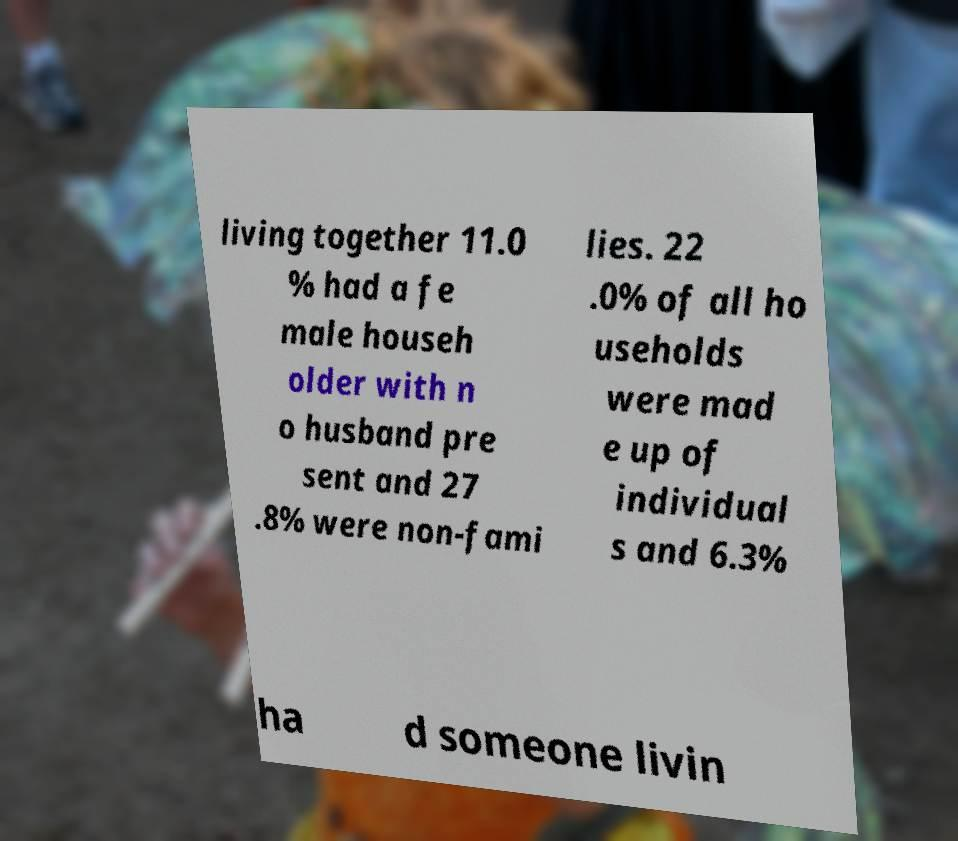I need the written content from this picture converted into text. Can you do that? living together 11.0 % had a fe male househ older with n o husband pre sent and 27 .8% were non-fami lies. 22 .0% of all ho useholds were mad e up of individual s and 6.3% ha d someone livin 